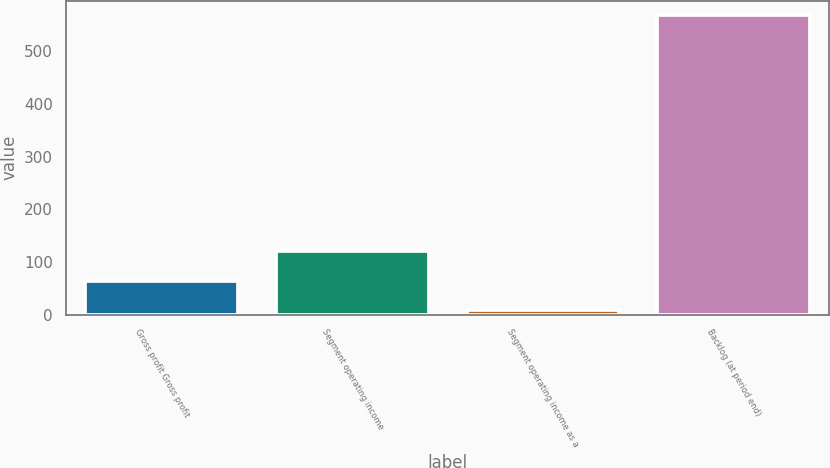<chart> <loc_0><loc_0><loc_500><loc_500><bar_chart><fcel>Gross profit Gross profit<fcel>Segment operating income<fcel>Segment operating income as a<fcel>Backlog (at period end)<nl><fcel>64.54<fcel>120.48<fcel>8.6<fcel>568<nl></chart> 